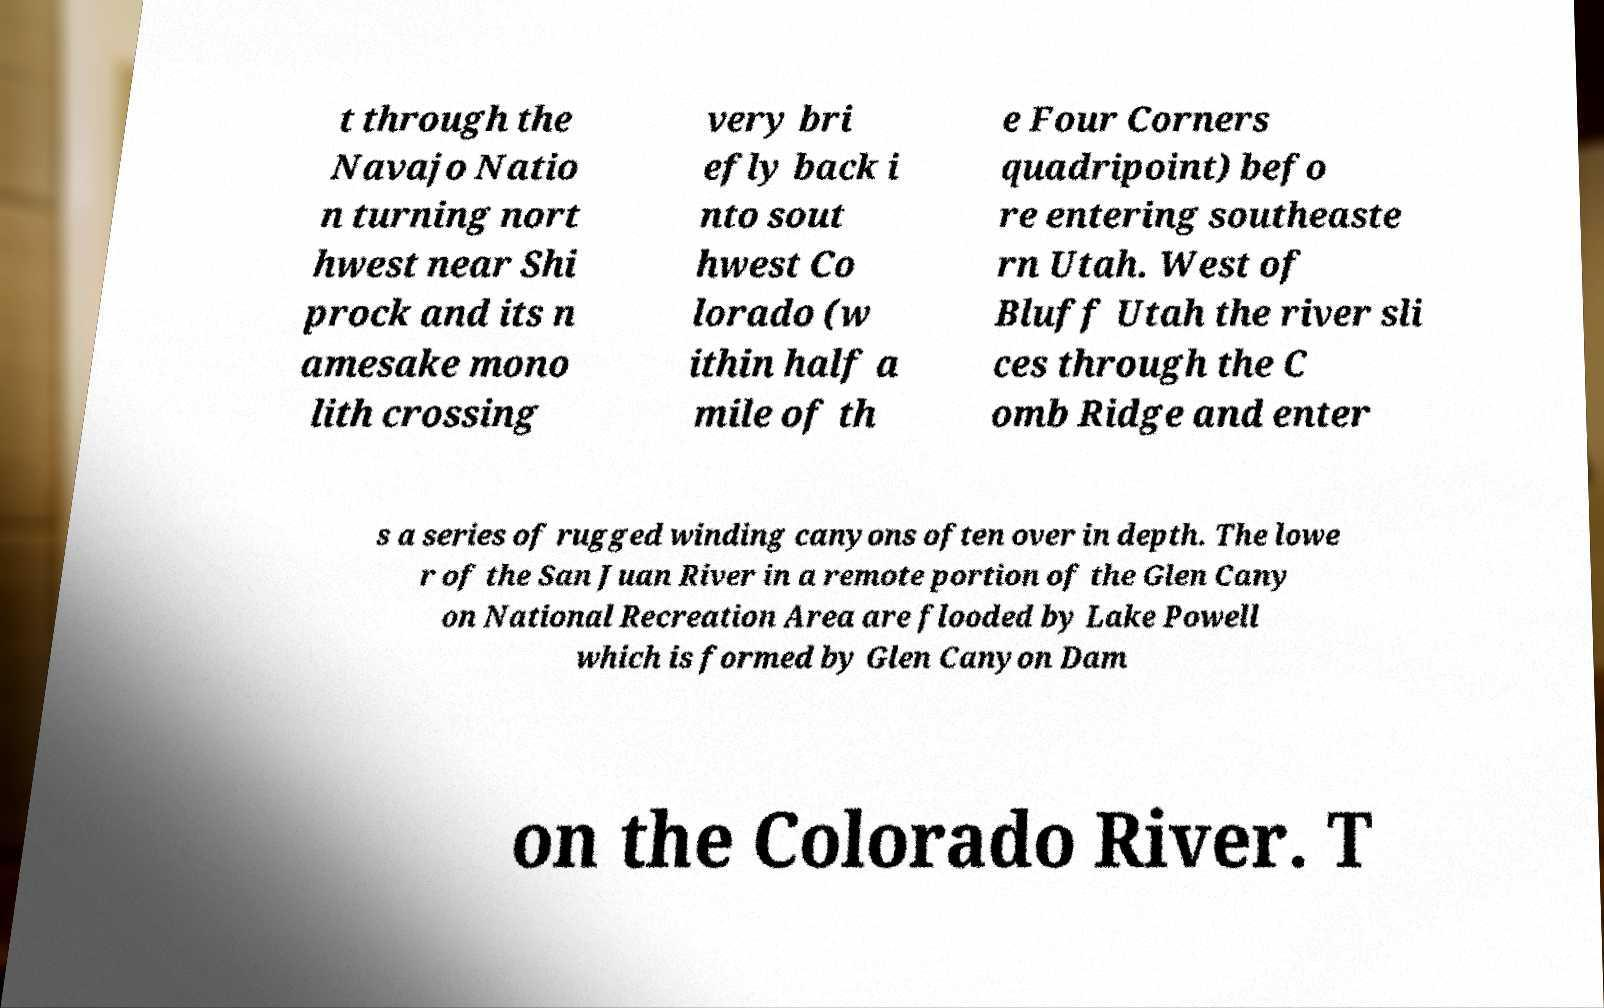Could you assist in decoding the text presented in this image and type it out clearly? t through the Navajo Natio n turning nort hwest near Shi prock and its n amesake mono lith crossing very bri efly back i nto sout hwest Co lorado (w ithin half a mile of th e Four Corners quadripoint) befo re entering southeaste rn Utah. West of Bluff Utah the river sli ces through the C omb Ridge and enter s a series of rugged winding canyons often over in depth. The lowe r of the San Juan River in a remote portion of the Glen Cany on National Recreation Area are flooded by Lake Powell which is formed by Glen Canyon Dam on the Colorado River. T 